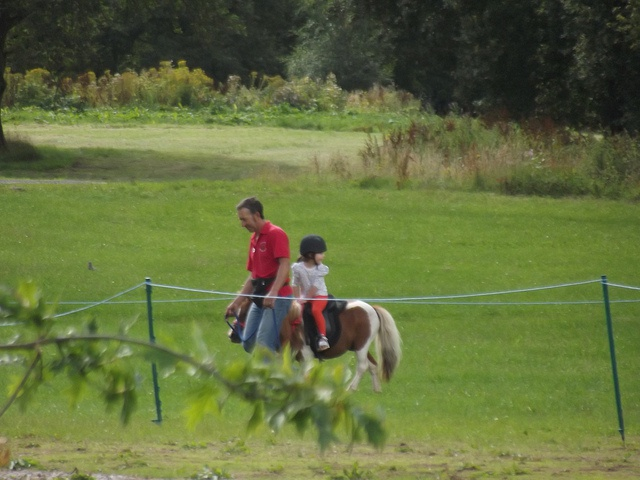Describe the objects in this image and their specific colors. I can see people in black, gray, brown, and maroon tones, horse in black, maroon, darkgray, and gray tones, and people in black, darkgray, and gray tones in this image. 